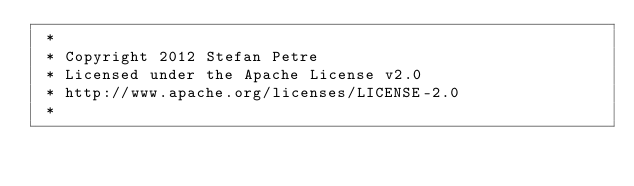Convert code to text. <code><loc_0><loc_0><loc_500><loc_500><_CSS_> *
 * Copyright 2012 Stefan Petre
 * Licensed under the Apache License v2.0
 * http://www.apache.org/licenses/LICENSE-2.0
 *</code> 